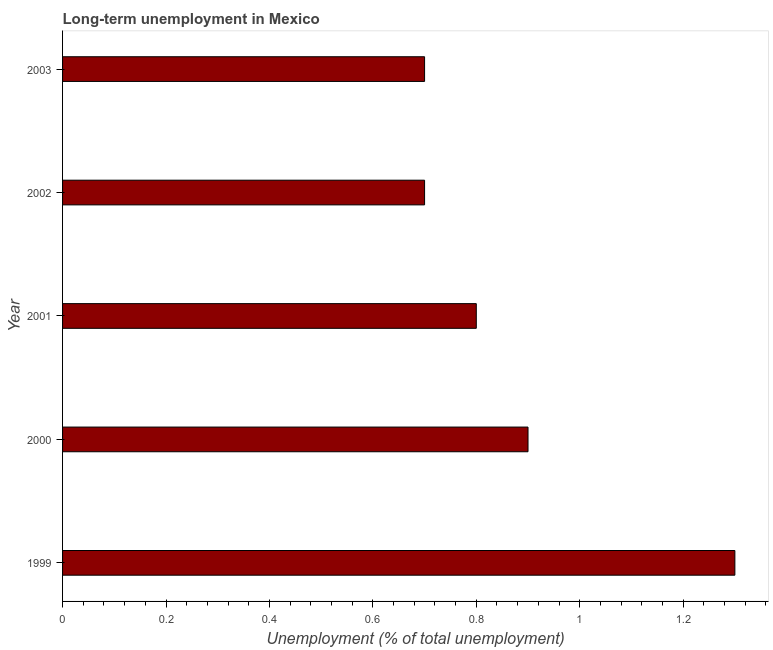Does the graph contain grids?
Provide a short and direct response. No. What is the title of the graph?
Your answer should be compact. Long-term unemployment in Mexico. What is the label or title of the X-axis?
Offer a very short reply. Unemployment (% of total unemployment). What is the long-term unemployment in 1999?
Provide a succinct answer. 1.3. Across all years, what is the maximum long-term unemployment?
Give a very brief answer. 1.3. Across all years, what is the minimum long-term unemployment?
Provide a succinct answer. 0.7. In which year was the long-term unemployment maximum?
Ensure brevity in your answer.  1999. In which year was the long-term unemployment minimum?
Ensure brevity in your answer.  2002. What is the sum of the long-term unemployment?
Provide a short and direct response. 4.4. What is the average long-term unemployment per year?
Ensure brevity in your answer.  0.88. What is the median long-term unemployment?
Provide a short and direct response. 0.8. In how many years, is the long-term unemployment greater than 0.48 %?
Give a very brief answer. 5. Do a majority of the years between 1999 and 2003 (inclusive) have long-term unemployment greater than 0.84 %?
Offer a terse response. No. What is the ratio of the long-term unemployment in 2000 to that in 2002?
Give a very brief answer. 1.29. Is the long-term unemployment in 1999 less than that in 2002?
Offer a terse response. No. What is the difference between the highest and the second highest long-term unemployment?
Keep it short and to the point. 0.4. Is the sum of the long-term unemployment in 2001 and 2003 greater than the maximum long-term unemployment across all years?
Keep it short and to the point. Yes. In how many years, is the long-term unemployment greater than the average long-term unemployment taken over all years?
Offer a terse response. 2. Are all the bars in the graph horizontal?
Keep it short and to the point. Yes. Are the values on the major ticks of X-axis written in scientific E-notation?
Make the answer very short. No. What is the Unemployment (% of total unemployment) in 1999?
Make the answer very short. 1.3. What is the Unemployment (% of total unemployment) in 2000?
Your answer should be very brief. 0.9. What is the Unemployment (% of total unemployment) in 2001?
Provide a short and direct response. 0.8. What is the Unemployment (% of total unemployment) of 2002?
Make the answer very short. 0.7. What is the Unemployment (% of total unemployment) of 2003?
Your response must be concise. 0.7. What is the difference between the Unemployment (% of total unemployment) in 1999 and 2000?
Your answer should be compact. 0.4. What is the difference between the Unemployment (% of total unemployment) in 1999 and 2003?
Keep it short and to the point. 0.6. What is the difference between the Unemployment (% of total unemployment) in 2000 and 2001?
Your response must be concise. 0.1. What is the difference between the Unemployment (% of total unemployment) in 2001 and 2002?
Provide a short and direct response. 0.1. What is the difference between the Unemployment (% of total unemployment) in 2002 and 2003?
Make the answer very short. 0. What is the ratio of the Unemployment (% of total unemployment) in 1999 to that in 2000?
Offer a very short reply. 1.44. What is the ratio of the Unemployment (% of total unemployment) in 1999 to that in 2001?
Your answer should be very brief. 1.62. What is the ratio of the Unemployment (% of total unemployment) in 1999 to that in 2002?
Provide a succinct answer. 1.86. What is the ratio of the Unemployment (% of total unemployment) in 1999 to that in 2003?
Provide a succinct answer. 1.86. What is the ratio of the Unemployment (% of total unemployment) in 2000 to that in 2001?
Provide a succinct answer. 1.12. What is the ratio of the Unemployment (% of total unemployment) in 2000 to that in 2002?
Offer a terse response. 1.29. What is the ratio of the Unemployment (% of total unemployment) in 2000 to that in 2003?
Your answer should be very brief. 1.29. What is the ratio of the Unemployment (% of total unemployment) in 2001 to that in 2002?
Give a very brief answer. 1.14. What is the ratio of the Unemployment (% of total unemployment) in 2001 to that in 2003?
Provide a succinct answer. 1.14. What is the ratio of the Unemployment (% of total unemployment) in 2002 to that in 2003?
Offer a very short reply. 1. 